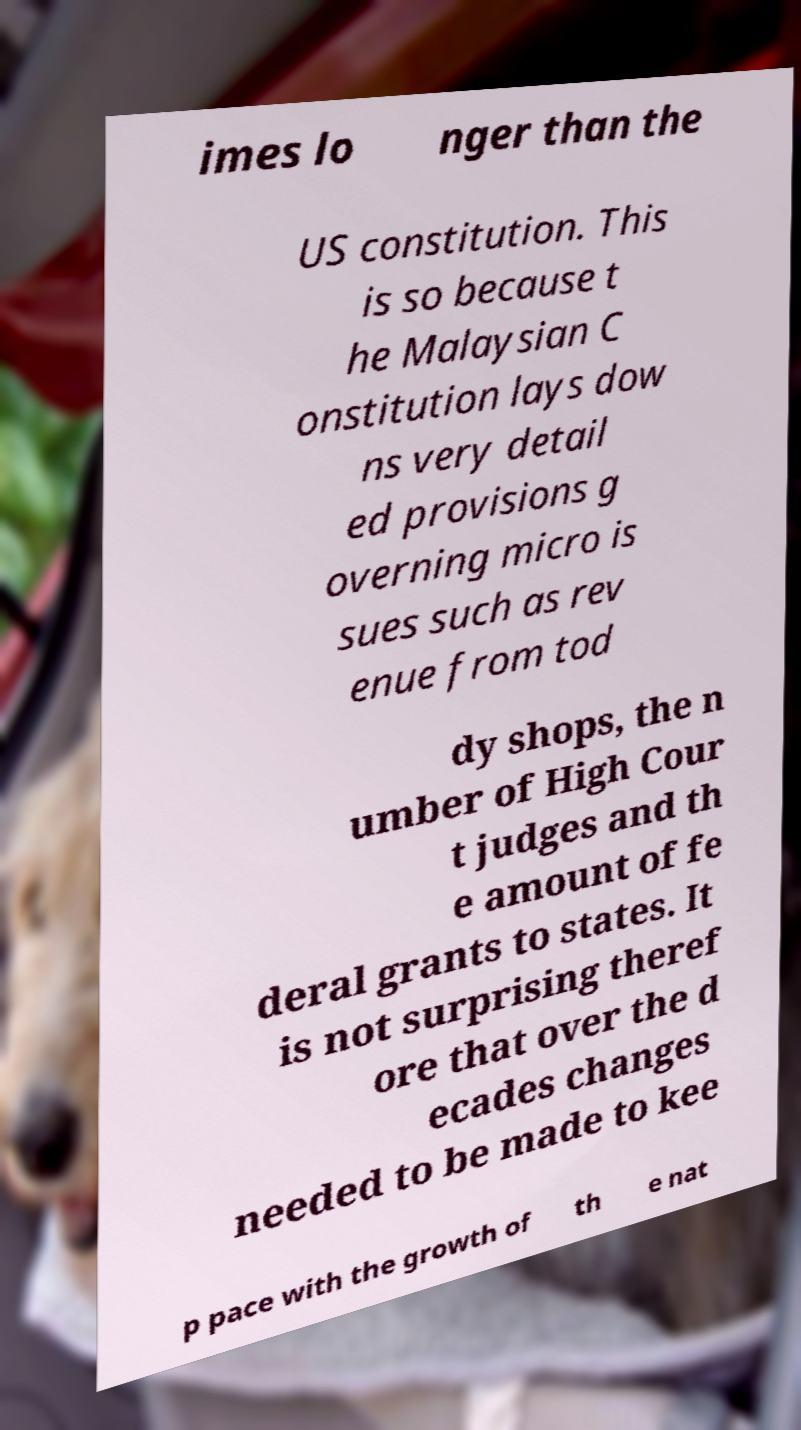What messages or text are displayed in this image? I need them in a readable, typed format. imes lo nger than the US constitution. This is so because t he Malaysian C onstitution lays dow ns very detail ed provisions g overning micro is sues such as rev enue from tod dy shops, the n umber of High Cour t judges and th e amount of fe deral grants to states. It is not surprising theref ore that over the d ecades changes needed to be made to kee p pace with the growth of th e nat 